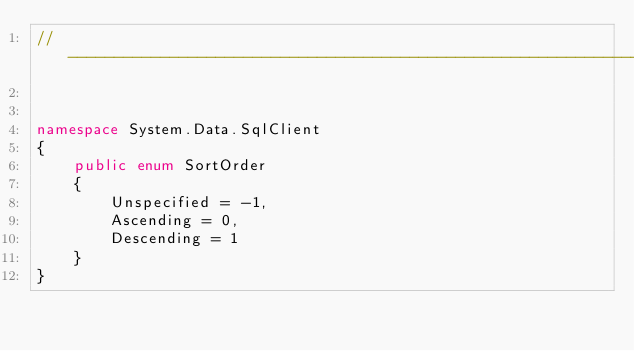Convert code to text. <code><loc_0><loc_0><loc_500><loc_500><_C#_>//------------------------------------------------------------------------------


namespace System.Data.SqlClient
{
    public enum SortOrder
    {
        Unspecified = -1,
        Ascending = 0,
        Descending = 1
    }
}

</code> 